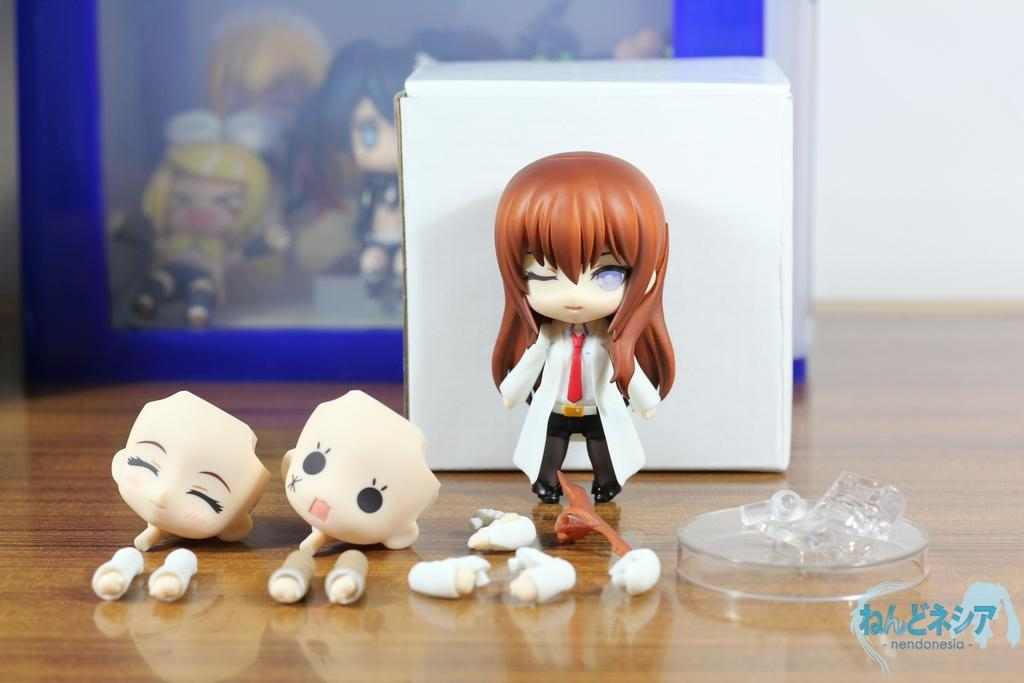What objects can be seen on the floor in the image? There are toys and a photo frame on the floor in the image. What type of objects are the toys? The provided facts do not specify the type of toys. What is displayed in the photo frame? The provided facts do not specify what is displayed in the photo frame. What type of cheese is being used to build the pipe in the image? There is no cheese or pipe present in the image. How many babies are crawling on the floor in the image? There are no babies present in the image. 